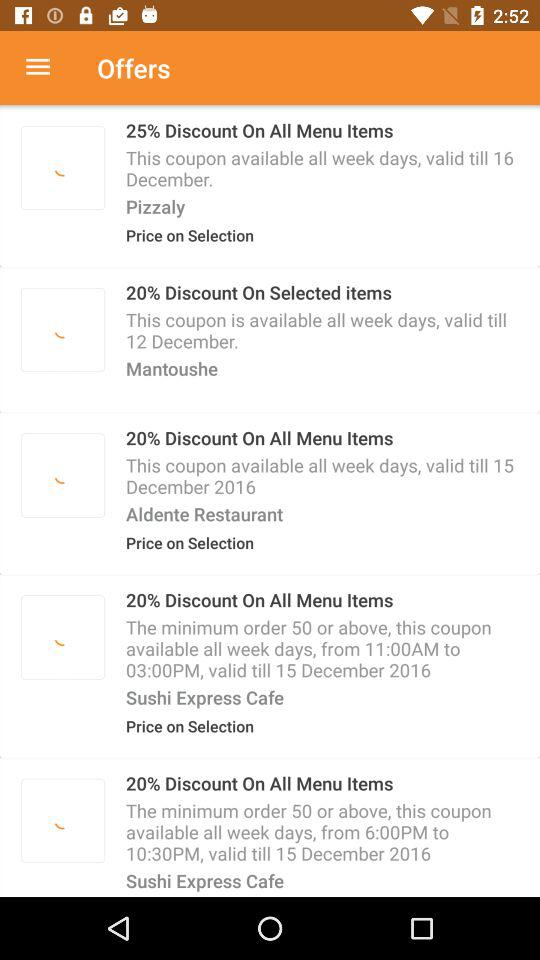How much is the discounted offer at Sushi Express Cafe? At Sushi Express Cafe, there is a discount of 20% on all menu items. 